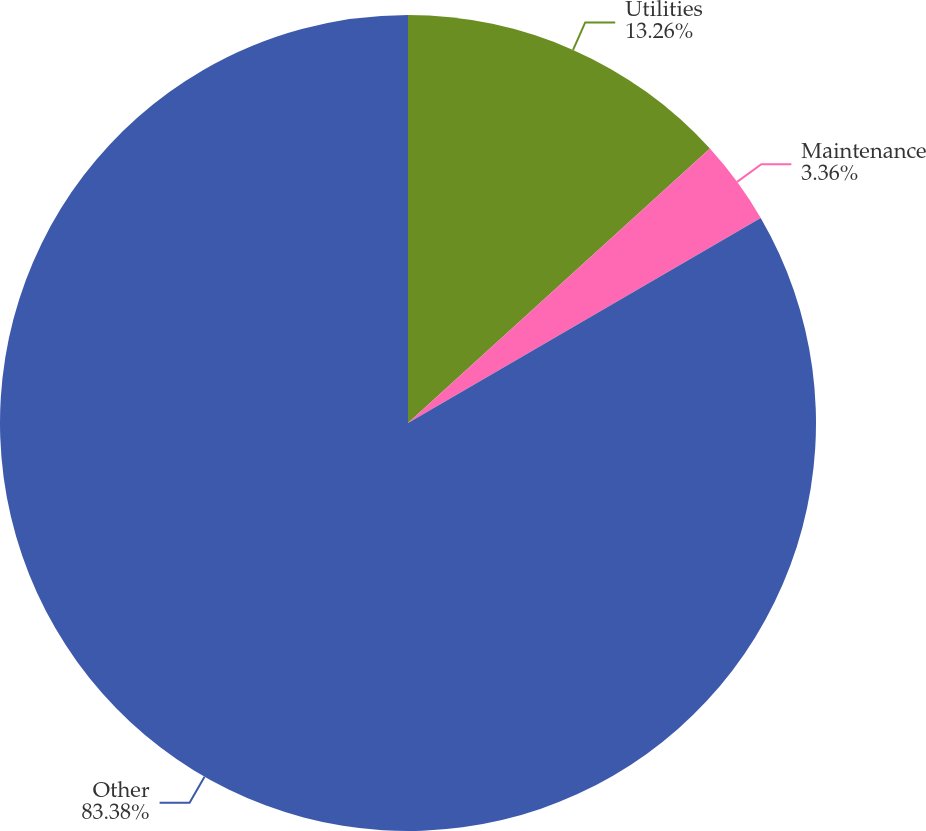Convert chart. <chart><loc_0><loc_0><loc_500><loc_500><pie_chart><fcel>Utilities<fcel>Maintenance<fcel>Other<nl><fcel>13.26%<fcel>3.36%<fcel>83.39%<nl></chart> 